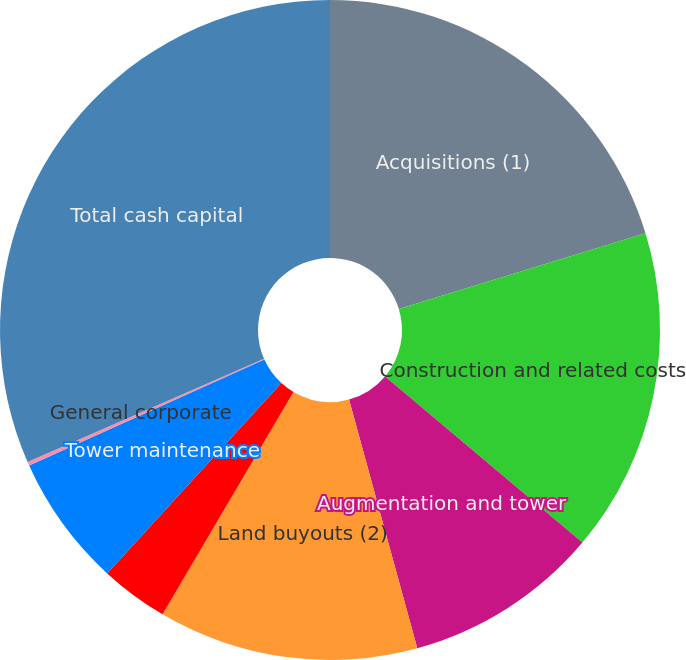Convert chart. <chart><loc_0><loc_0><loc_500><loc_500><pie_chart><fcel>Acquisitions (1)<fcel>Construction and related costs<fcel>Augmentation and tower<fcel>Land buyouts (2)<fcel>Purchase and refurbishment of<fcel>Tower maintenance<fcel>General corporate<fcel>Total cash capital<nl><fcel>20.27%<fcel>15.87%<fcel>9.6%<fcel>12.73%<fcel>3.33%<fcel>6.46%<fcel>0.19%<fcel>31.55%<nl></chart> 